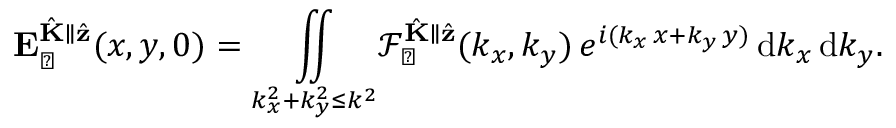Convert formula to latex. <formula><loc_0><loc_0><loc_500><loc_500>E _ { \perp } ^ { \hat { K } \| \hat { z } } ( x , y , 0 ) = \underset { k _ { x } ^ { 2 } + k _ { y } ^ { 2 } \leq k ^ { 2 } } { \iint } \mathcal { F } _ { \perp } ^ { \hat { K } \| \hat { z } } ( k _ { x } , k _ { y } ) \, e ^ { i ( k _ { x } \, x + k _ { y } \, y ) } \, d k _ { x } \, d k _ { y } .</formula> 